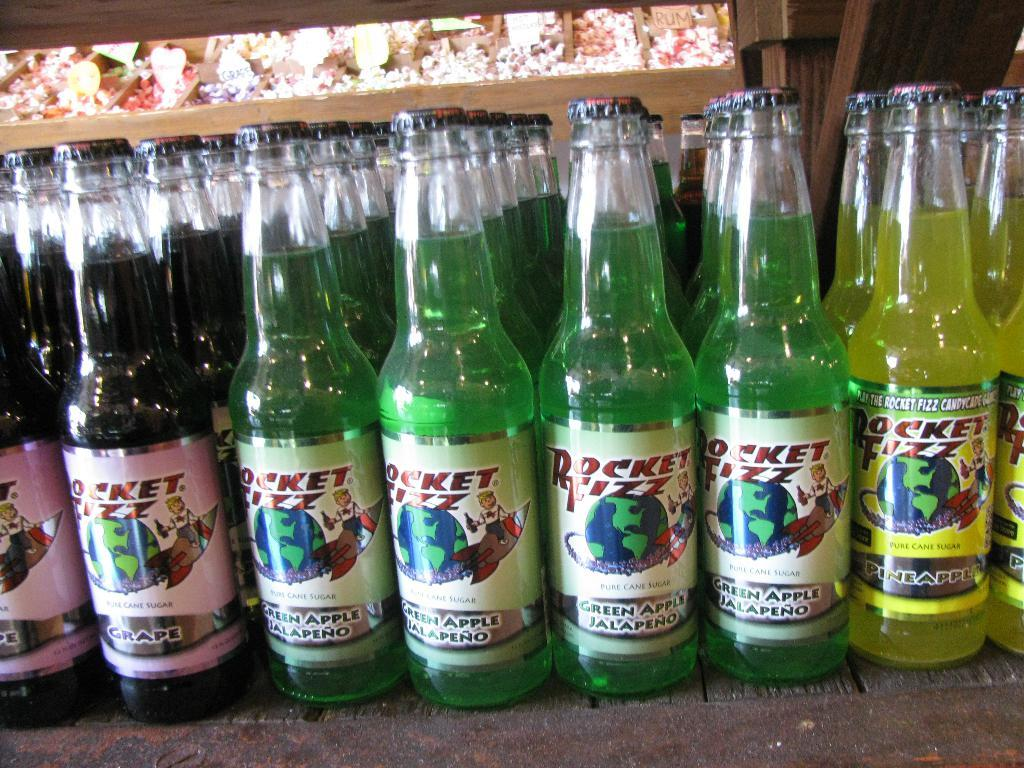<image>
Write a terse but informative summary of the picture. A collection of different flavor Rocket Fizz drinks in glass bottles on a shelf. 